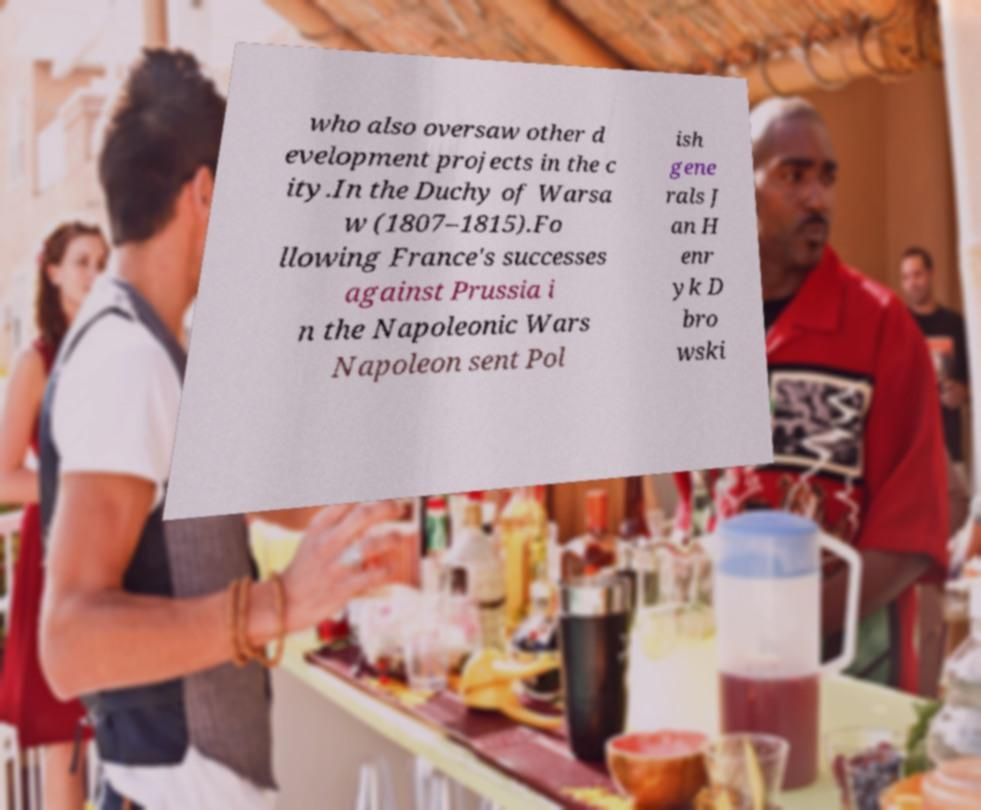Can you accurately transcribe the text from the provided image for me? who also oversaw other d evelopment projects in the c ity.In the Duchy of Warsa w (1807–1815).Fo llowing France's successes against Prussia i n the Napoleonic Wars Napoleon sent Pol ish gene rals J an H enr yk D bro wski 